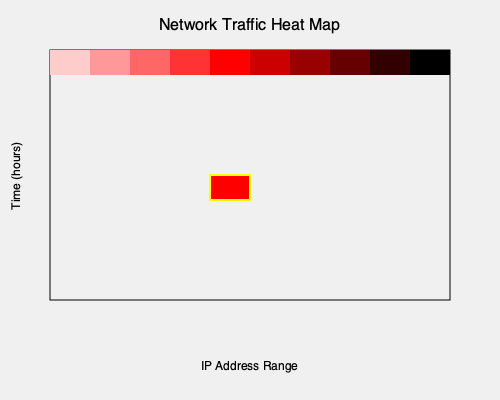Analyze the heat map visualization of network traffic data. Which of the following statements best describes the anomaly detected in the visualization?

A) There is an unusual spike in traffic from a specific IP range during off-peak hours
B) The overall traffic pattern shows a gradual increase throughout the day
C) There is a consistent low level of traffic across all IP ranges
D) The visualization shows no significant anomalies in network traffic To identify anomalies in the network traffic heat map, we need to follow these steps:

1. Understand the heat map representation:
   - The x-axis represents the IP address range
   - The y-axis represents time (in hours)
   - The color intensity indicates the volume of network traffic (darker = higher volume)

2. Analyze the general pattern:
   - Most of the heat map shows a relatively consistent low to moderate level of traffic (light to medium red colors)

3. Identify any unusual patterns:
   - There is a single cell with a bright red color, outlined in yellow
   - This cell is located approximately in the middle of the IP range and around the middle of the time range

4. Interpret the anomaly:
   - The bright red color indicates a significantly higher volume of traffic compared to the surrounding cells
   - Its position suggests it occurred during a specific time frame for a particular IP range
   - This pattern is consistent with a sudden spike in traffic from a specific IP range during what might be considered off-peak hours

5. Compare with the given options:
   - Option A accurately describes the observed anomaly
   - Options B, C, and D do not match the visualization

Based on this analysis, the anomaly detected in the visualization is best described as an unusual spike in traffic from a specific IP range during off-peak hours.
Answer: A) There is an unusual spike in traffic from a specific IP range during off-peak hours 